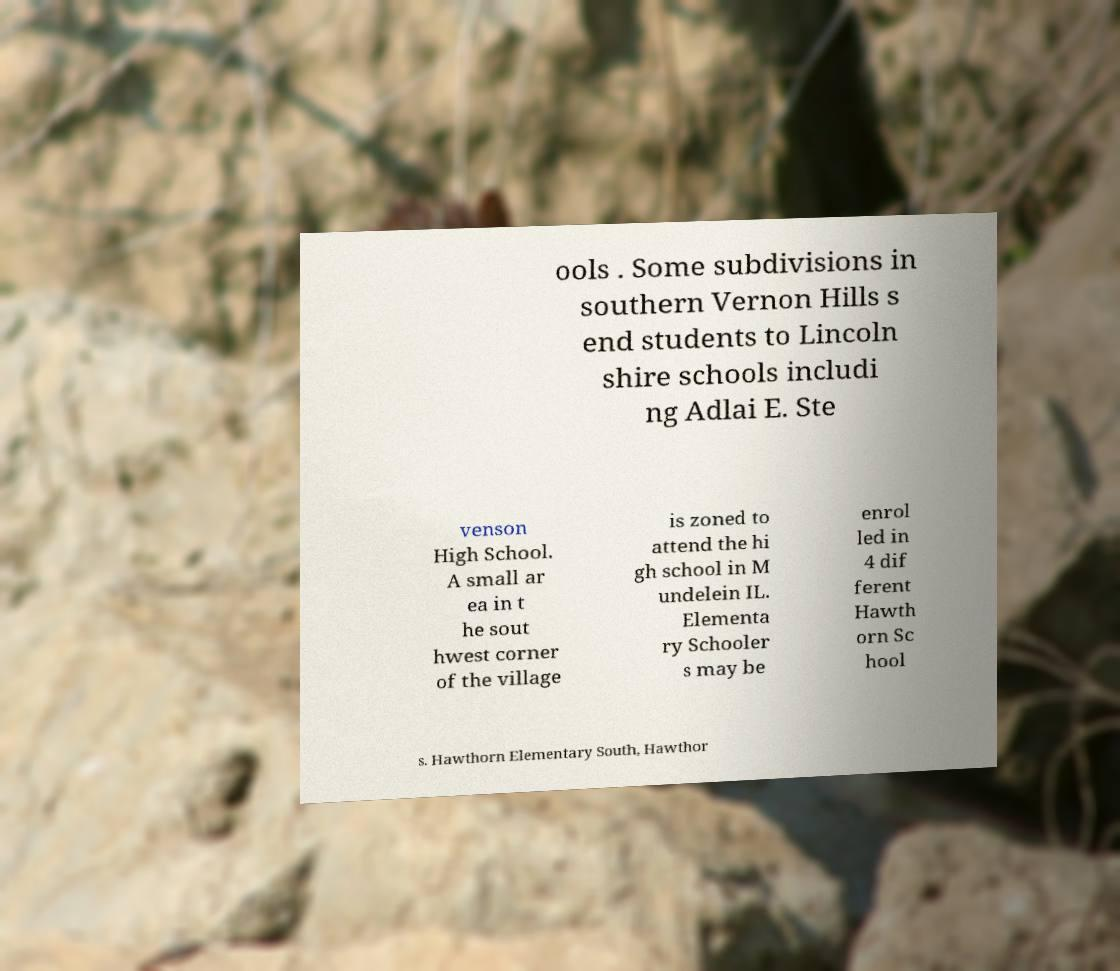Could you extract and type out the text from this image? ools . Some subdivisions in southern Vernon Hills s end students to Lincoln shire schools includi ng Adlai E. Ste venson High School. A small ar ea in t he sout hwest corner of the village is zoned to attend the hi gh school in M undelein IL. Elementa ry Schooler s may be enrol led in 4 dif ferent Hawth orn Sc hool s. Hawthorn Elementary South, Hawthor 